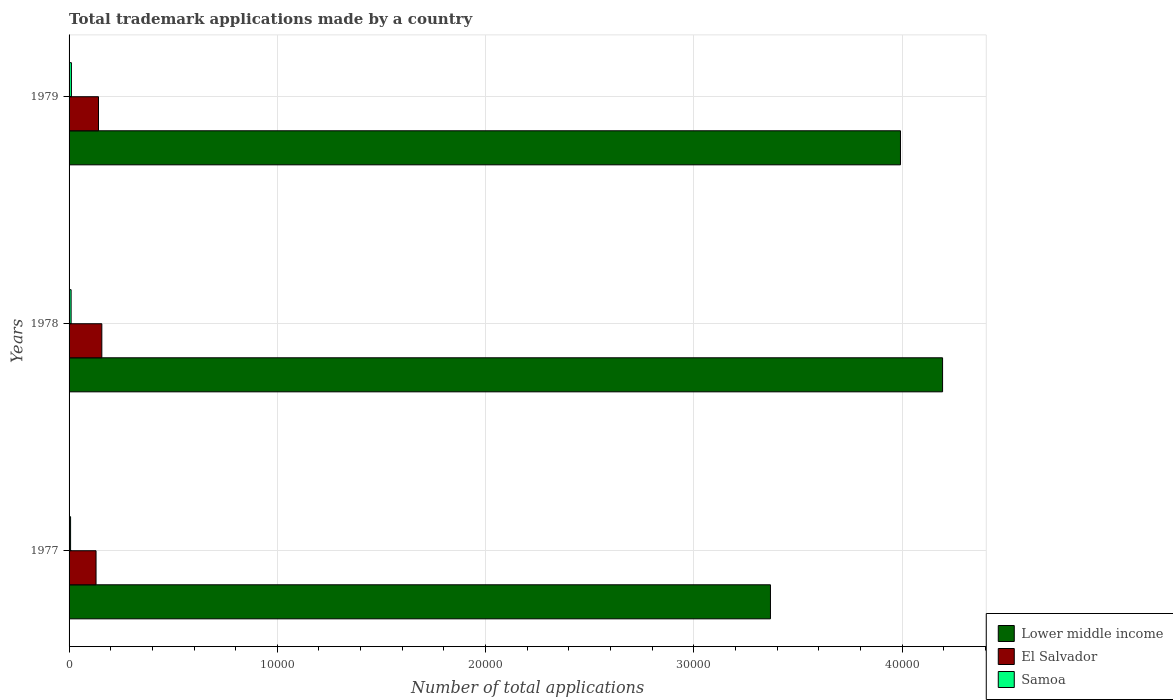How many groups of bars are there?
Offer a terse response. 3. Are the number of bars on each tick of the Y-axis equal?
Your answer should be very brief. Yes. How many bars are there on the 3rd tick from the bottom?
Your response must be concise. 3. In how many cases, is the number of bars for a given year not equal to the number of legend labels?
Provide a succinct answer. 0. What is the number of applications made by in Lower middle income in 1977?
Give a very brief answer. 3.37e+04. Across all years, what is the maximum number of applications made by in Samoa?
Ensure brevity in your answer.  113. Across all years, what is the minimum number of applications made by in Lower middle income?
Offer a terse response. 3.37e+04. In which year was the number of applications made by in Samoa maximum?
Ensure brevity in your answer.  1979. In which year was the number of applications made by in Lower middle income minimum?
Your response must be concise. 1977. What is the total number of applications made by in El Salvador in the graph?
Your answer should be very brief. 4281. What is the difference between the number of applications made by in Samoa in 1977 and that in 1978?
Provide a succinct answer. -26. What is the difference between the number of applications made by in El Salvador in 1978 and the number of applications made by in Lower middle income in 1977?
Provide a succinct answer. -3.21e+04. What is the average number of applications made by in El Salvador per year?
Your response must be concise. 1427. In the year 1977, what is the difference between the number of applications made by in Samoa and number of applications made by in Lower middle income?
Your answer should be very brief. -3.36e+04. What is the ratio of the number of applications made by in El Salvador in 1978 to that in 1979?
Your response must be concise. 1.11. Is the number of applications made by in Lower middle income in 1977 less than that in 1979?
Your answer should be compact. Yes. Is the difference between the number of applications made by in Samoa in 1977 and 1979 greater than the difference between the number of applications made by in Lower middle income in 1977 and 1979?
Your answer should be very brief. Yes. What is the difference between the highest and the lowest number of applications made by in El Salvador?
Make the answer very short. 278. Is the sum of the number of applications made by in El Salvador in 1978 and 1979 greater than the maximum number of applications made by in Lower middle income across all years?
Offer a terse response. No. What does the 2nd bar from the top in 1979 represents?
Your answer should be compact. El Salvador. What does the 3rd bar from the bottom in 1977 represents?
Your response must be concise. Samoa. How many years are there in the graph?
Ensure brevity in your answer.  3. Are the values on the major ticks of X-axis written in scientific E-notation?
Your answer should be very brief. No. Does the graph contain grids?
Your response must be concise. Yes. How many legend labels are there?
Make the answer very short. 3. What is the title of the graph?
Your answer should be very brief. Total trademark applications made by a country. Does "Sint Maarten (Dutch part)" appear as one of the legend labels in the graph?
Provide a succinct answer. No. What is the label or title of the X-axis?
Provide a succinct answer. Number of total applications. What is the label or title of the Y-axis?
Give a very brief answer. Years. What is the Number of total applications of Lower middle income in 1977?
Ensure brevity in your answer.  3.37e+04. What is the Number of total applications of El Salvador in 1977?
Offer a terse response. 1295. What is the Number of total applications in Lower middle income in 1978?
Provide a short and direct response. 4.19e+04. What is the Number of total applications in El Salvador in 1978?
Your answer should be very brief. 1573. What is the Number of total applications of Lower middle income in 1979?
Provide a short and direct response. 3.99e+04. What is the Number of total applications in El Salvador in 1979?
Offer a terse response. 1413. What is the Number of total applications of Samoa in 1979?
Offer a terse response. 113. Across all years, what is the maximum Number of total applications of Lower middle income?
Ensure brevity in your answer.  4.19e+04. Across all years, what is the maximum Number of total applications in El Salvador?
Keep it short and to the point. 1573. Across all years, what is the maximum Number of total applications in Samoa?
Your answer should be compact. 113. Across all years, what is the minimum Number of total applications of Lower middle income?
Your answer should be very brief. 3.37e+04. Across all years, what is the minimum Number of total applications of El Salvador?
Offer a very short reply. 1295. What is the total Number of total applications of Lower middle income in the graph?
Provide a succinct answer. 1.16e+05. What is the total Number of total applications of El Salvador in the graph?
Your answer should be very brief. 4281. What is the total Number of total applications in Samoa in the graph?
Provide a short and direct response. 283. What is the difference between the Number of total applications in Lower middle income in 1977 and that in 1978?
Keep it short and to the point. -8265. What is the difference between the Number of total applications of El Salvador in 1977 and that in 1978?
Your response must be concise. -278. What is the difference between the Number of total applications in Samoa in 1977 and that in 1978?
Give a very brief answer. -26. What is the difference between the Number of total applications in Lower middle income in 1977 and that in 1979?
Make the answer very short. -6243. What is the difference between the Number of total applications of El Salvador in 1977 and that in 1979?
Keep it short and to the point. -118. What is the difference between the Number of total applications of Samoa in 1977 and that in 1979?
Offer a very short reply. -41. What is the difference between the Number of total applications in Lower middle income in 1978 and that in 1979?
Your answer should be very brief. 2022. What is the difference between the Number of total applications of El Salvador in 1978 and that in 1979?
Your answer should be compact. 160. What is the difference between the Number of total applications of Samoa in 1978 and that in 1979?
Your answer should be very brief. -15. What is the difference between the Number of total applications in Lower middle income in 1977 and the Number of total applications in El Salvador in 1978?
Offer a very short reply. 3.21e+04. What is the difference between the Number of total applications of Lower middle income in 1977 and the Number of total applications of Samoa in 1978?
Your answer should be compact. 3.36e+04. What is the difference between the Number of total applications in El Salvador in 1977 and the Number of total applications in Samoa in 1978?
Your answer should be very brief. 1197. What is the difference between the Number of total applications of Lower middle income in 1977 and the Number of total applications of El Salvador in 1979?
Offer a very short reply. 3.23e+04. What is the difference between the Number of total applications of Lower middle income in 1977 and the Number of total applications of Samoa in 1979?
Your response must be concise. 3.36e+04. What is the difference between the Number of total applications of El Salvador in 1977 and the Number of total applications of Samoa in 1979?
Offer a very short reply. 1182. What is the difference between the Number of total applications of Lower middle income in 1978 and the Number of total applications of El Salvador in 1979?
Make the answer very short. 4.05e+04. What is the difference between the Number of total applications in Lower middle income in 1978 and the Number of total applications in Samoa in 1979?
Ensure brevity in your answer.  4.18e+04. What is the difference between the Number of total applications in El Salvador in 1978 and the Number of total applications in Samoa in 1979?
Provide a short and direct response. 1460. What is the average Number of total applications in Lower middle income per year?
Your answer should be compact. 3.85e+04. What is the average Number of total applications in El Salvador per year?
Your answer should be compact. 1427. What is the average Number of total applications of Samoa per year?
Your response must be concise. 94.33. In the year 1977, what is the difference between the Number of total applications of Lower middle income and Number of total applications of El Salvador?
Your response must be concise. 3.24e+04. In the year 1977, what is the difference between the Number of total applications of Lower middle income and Number of total applications of Samoa?
Offer a very short reply. 3.36e+04. In the year 1977, what is the difference between the Number of total applications in El Salvador and Number of total applications in Samoa?
Offer a very short reply. 1223. In the year 1978, what is the difference between the Number of total applications in Lower middle income and Number of total applications in El Salvador?
Ensure brevity in your answer.  4.04e+04. In the year 1978, what is the difference between the Number of total applications in Lower middle income and Number of total applications in Samoa?
Ensure brevity in your answer.  4.18e+04. In the year 1978, what is the difference between the Number of total applications of El Salvador and Number of total applications of Samoa?
Make the answer very short. 1475. In the year 1979, what is the difference between the Number of total applications in Lower middle income and Number of total applications in El Salvador?
Your answer should be compact. 3.85e+04. In the year 1979, what is the difference between the Number of total applications in Lower middle income and Number of total applications in Samoa?
Keep it short and to the point. 3.98e+04. In the year 1979, what is the difference between the Number of total applications in El Salvador and Number of total applications in Samoa?
Make the answer very short. 1300. What is the ratio of the Number of total applications of Lower middle income in 1977 to that in 1978?
Make the answer very short. 0.8. What is the ratio of the Number of total applications in El Salvador in 1977 to that in 1978?
Give a very brief answer. 0.82. What is the ratio of the Number of total applications in Samoa in 1977 to that in 1978?
Your response must be concise. 0.73. What is the ratio of the Number of total applications of Lower middle income in 1977 to that in 1979?
Keep it short and to the point. 0.84. What is the ratio of the Number of total applications of El Salvador in 1977 to that in 1979?
Provide a short and direct response. 0.92. What is the ratio of the Number of total applications in Samoa in 1977 to that in 1979?
Keep it short and to the point. 0.64. What is the ratio of the Number of total applications in Lower middle income in 1978 to that in 1979?
Your answer should be compact. 1.05. What is the ratio of the Number of total applications in El Salvador in 1978 to that in 1979?
Your response must be concise. 1.11. What is the ratio of the Number of total applications in Samoa in 1978 to that in 1979?
Ensure brevity in your answer.  0.87. What is the difference between the highest and the second highest Number of total applications of Lower middle income?
Make the answer very short. 2022. What is the difference between the highest and the second highest Number of total applications in El Salvador?
Ensure brevity in your answer.  160. What is the difference between the highest and the lowest Number of total applications of Lower middle income?
Keep it short and to the point. 8265. What is the difference between the highest and the lowest Number of total applications of El Salvador?
Give a very brief answer. 278. What is the difference between the highest and the lowest Number of total applications of Samoa?
Your answer should be very brief. 41. 